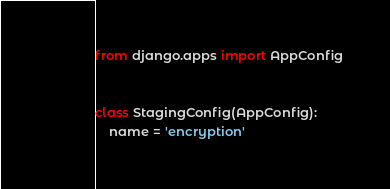<code> <loc_0><loc_0><loc_500><loc_500><_Python_>from django.apps import AppConfig


class StagingConfig(AppConfig):
    name = 'encryption'
</code> 